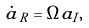Convert formula to latex. <formula><loc_0><loc_0><loc_500><loc_500>\dot { \tilde { a } } _ { R } = \tilde { \Omega } \tilde { a } _ { I } ,</formula> 